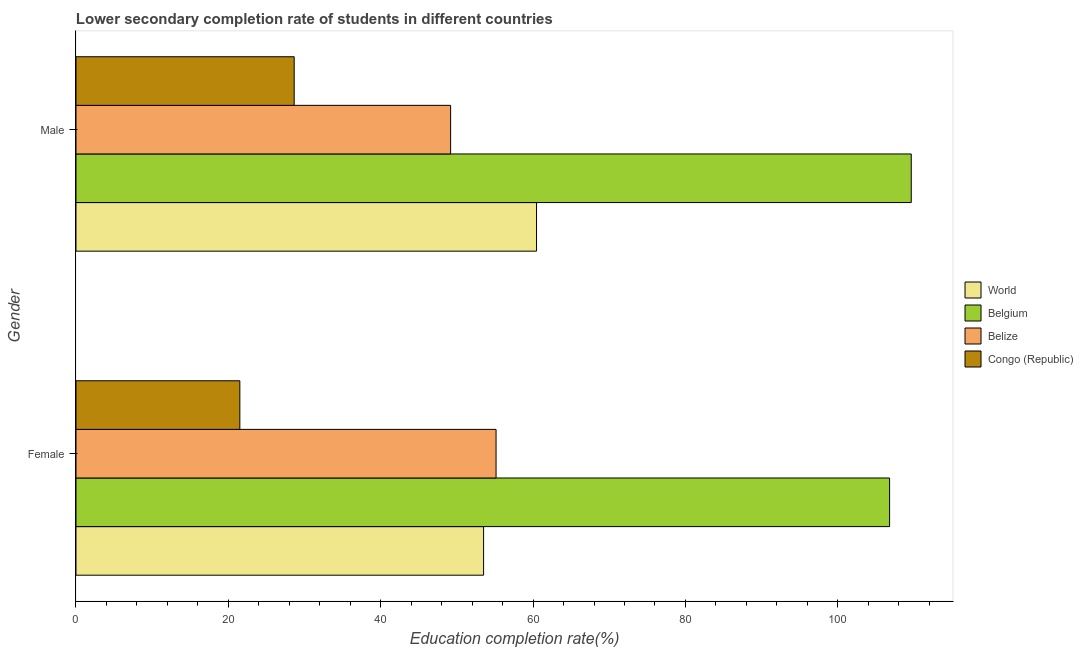How many different coloured bars are there?
Offer a very short reply. 4. Are the number of bars on each tick of the Y-axis equal?
Your answer should be compact. Yes. How many bars are there on the 1st tick from the top?
Provide a short and direct response. 4. What is the education completion rate of male students in World?
Offer a terse response. 60.46. Across all countries, what is the maximum education completion rate of male students?
Give a very brief answer. 109.65. Across all countries, what is the minimum education completion rate of male students?
Make the answer very short. 28.64. In which country was the education completion rate of male students minimum?
Ensure brevity in your answer.  Congo (Republic). What is the total education completion rate of female students in the graph?
Offer a very short reply. 236.96. What is the difference between the education completion rate of male students in Congo (Republic) and that in World?
Your answer should be compact. -31.81. What is the difference between the education completion rate of female students in Belize and the education completion rate of male students in Congo (Republic)?
Your answer should be very brief. 26.5. What is the average education completion rate of male students per country?
Your response must be concise. 61.98. What is the difference between the education completion rate of male students and education completion rate of female students in Congo (Republic)?
Provide a succinct answer. 7.13. In how many countries, is the education completion rate of male students greater than 84 %?
Your answer should be very brief. 1. What is the ratio of the education completion rate of female students in Belgium to that in Belize?
Provide a succinct answer. 1.94. Is the education completion rate of female students in Congo (Republic) less than that in Belize?
Provide a succinct answer. Yes. In how many countries, is the education completion rate of female students greater than the average education completion rate of female students taken over all countries?
Provide a short and direct response. 1. What does the 1st bar from the top in Female represents?
Your answer should be very brief. Congo (Republic). What does the 3rd bar from the bottom in Male represents?
Your answer should be very brief. Belize. Are all the bars in the graph horizontal?
Offer a very short reply. Yes. What is the difference between two consecutive major ticks on the X-axis?
Provide a succinct answer. 20. Where does the legend appear in the graph?
Ensure brevity in your answer.  Center right. What is the title of the graph?
Make the answer very short. Lower secondary completion rate of students in different countries. What is the label or title of the X-axis?
Provide a succinct answer. Education completion rate(%). What is the label or title of the Y-axis?
Offer a terse response. Gender. What is the Education completion rate(%) in World in Female?
Your answer should be compact. 53.51. What is the Education completion rate(%) in Belgium in Female?
Give a very brief answer. 106.8. What is the Education completion rate(%) in Belize in Female?
Ensure brevity in your answer.  55.14. What is the Education completion rate(%) in Congo (Republic) in Female?
Your answer should be very brief. 21.51. What is the Education completion rate(%) of World in Male?
Offer a terse response. 60.46. What is the Education completion rate(%) of Belgium in Male?
Keep it short and to the point. 109.65. What is the Education completion rate(%) of Belize in Male?
Offer a terse response. 49.18. What is the Education completion rate(%) of Congo (Republic) in Male?
Provide a succinct answer. 28.64. Across all Gender, what is the maximum Education completion rate(%) of World?
Offer a very short reply. 60.46. Across all Gender, what is the maximum Education completion rate(%) of Belgium?
Your answer should be compact. 109.65. Across all Gender, what is the maximum Education completion rate(%) of Belize?
Your answer should be very brief. 55.14. Across all Gender, what is the maximum Education completion rate(%) of Congo (Republic)?
Offer a terse response. 28.64. Across all Gender, what is the minimum Education completion rate(%) of World?
Make the answer very short. 53.51. Across all Gender, what is the minimum Education completion rate(%) of Belgium?
Your answer should be very brief. 106.8. Across all Gender, what is the minimum Education completion rate(%) of Belize?
Keep it short and to the point. 49.18. Across all Gender, what is the minimum Education completion rate(%) in Congo (Republic)?
Provide a succinct answer. 21.51. What is the total Education completion rate(%) in World in the graph?
Your response must be concise. 113.96. What is the total Education completion rate(%) in Belgium in the graph?
Offer a very short reply. 216.45. What is the total Education completion rate(%) of Belize in the graph?
Offer a very short reply. 104.32. What is the total Education completion rate(%) in Congo (Republic) in the graph?
Your answer should be compact. 50.15. What is the difference between the Education completion rate(%) in World in Female and that in Male?
Your response must be concise. -6.95. What is the difference between the Education completion rate(%) in Belgium in Female and that in Male?
Offer a terse response. -2.84. What is the difference between the Education completion rate(%) of Belize in Female and that in Male?
Your answer should be compact. 5.97. What is the difference between the Education completion rate(%) in Congo (Republic) in Female and that in Male?
Your answer should be compact. -7.13. What is the difference between the Education completion rate(%) in World in Female and the Education completion rate(%) in Belgium in Male?
Offer a terse response. -56.14. What is the difference between the Education completion rate(%) in World in Female and the Education completion rate(%) in Belize in Male?
Provide a succinct answer. 4.33. What is the difference between the Education completion rate(%) of World in Female and the Education completion rate(%) of Congo (Republic) in Male?
Your answer should be compact. 24.86. What is the difference between the Education completion rate(%) of Belgium in Female and the Education completion rate(%) of Belize in Male?
Keep it short and to the point. 57.63. What is the difference between the Education completion rate(%) in Belgium in Female and the Education completion rate(%) in Congo (Republic) in Male?
Provide a short and direct response. 78.16. What is the difference between the Education completion rate(%) in Belize in Female and the Education completion rate(%) in Congo (Republic) in Male?
Provide a short and direct response. 26.5. What is the average Education completion rate(%) in World per Gender?
Make the answer very short. 56.98. What is the average Education completion rate(%) in Belgium per Gender?
Your answer should be very brief. 108.22. What is the average Education completion rate(%) of Belize per Gender?
Keep it short and to the point. 52.16. What is the average Education completion rate(%) of Congo (Republic) per Gender?
Provide a short and direct response. 25.08. What is the difference between the Education completion rate(%) of World and Education completion rate(%) of Belgium in Female?
Offer a terse response. -53.3. What is the difference between the Education completion rate(%) in World and Education completion rate(%) in Belize in Female?
Your answer should be very brief. -1.64. What is the difference between the Education completion rate(%) of World and Education completion rate(%) of Congo (Republic) in Female?
Offer a very short reply. 32. What is the difference between the Education completion rate(%) in Belgium and Education completion rate(%) in Belize in Female?
Give a very brief answer. 51.66. What is the difference between the Education completion rate(%) in Belgium and Education completion rate(%) in Congo (Republic) in Female?
Keep it short and to the point. 85.29. What is the difference between the Education completion rate(%) in Belize and Education completion rate(%) in Congo (Republic) in Female?
Ensure brevity in your answer.  33.64. What is the difference between the Education completion rate(%) in World and Education completion rate(%) in Belgium in Male?
Your answer should be compact. -49.19. What is the difference between the Education completion rate(%) of World and Education completion rate(%) of Belize in Male?
Ensure brevity in your answer.  11.28. What is the difference between the Education completion rate(%) of World and Education completion rate(%) of Congo (Republic) in Male?
Your answer should be very brief. 31.81. What is the difference between the Education completion rate(%) in Belgium and Education completion rate(%) in Belize in Male?
Your answer should be very brief. 60.47. What is the difference between the Education completion rate(%) of Belgium and Education completion rate(%) of Congo (Republic) in Male?
Your answer should be compact. 81. What is the difference between the Education completion rate(%) of Belize and Education completion rate(%) of Congo (Republic) in Male?
Provide a short and direct response. 20.53. What is the ratio of the Education completion rate(%) of World in Female to that in Male?
Make the answer very short. 0.89. What is the ratio of the Education completion rate(%) of Belgium in Female to that in Male?
Provide a short and direct response. 0.97. What is the ratio of the Education completion rate(%) of Belize in Female to that in Male?
Offer a very short reply. 1.12. What is the ratio of the Education completion rate(%) in Congo (Republic) in Female to that in Male?
Your answer should be compact. 0.75. What is the difference between the highest and the second highest Education completion rate(%) of World?
Offer a terse response. 6.95. What is the difference between the highest and the second highest Education completion rate(%) of Belgium?
Keep it short and to the point. 2.84. What is the difference between the highest and the second highest Education completion rate(%) of Belize?
Keep it short and to the point. 5.97. What is the difference between the highest and the second highest Education completion rate(%) of Congo (Republic)?
Your answer should be very brief. 7.13. What is the difference between the highest and the lowest Education completion rate(%) in World?
Your answer should be compact. 6.95. What is the difference between the highest and the lowest Education completion rate(%) in Belgium?
Keep it short and to the point. 2.84. What is the difference between the highest and the lowest Education completion rate(%) of Belize?
Your answer should be very brief. 5.97. What is the difference between the highest and the lowest Education completion rate(%) of Congo (Republic)?
Give a very brief answer. 7.13. 